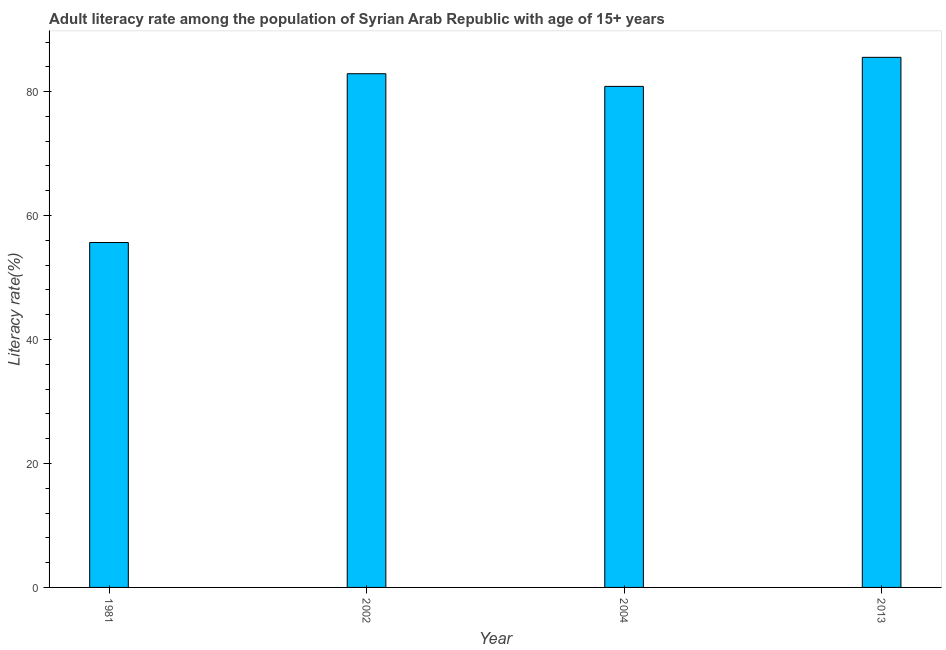Does the graph contain any zero values?
Your answer should be compact. No. What is the title of the graph?
Give a very brief answer. Adult literacy rate among the population of Syrian Arab Republic with age of 15+ years. What is the label or title of the Y-axis?
Your answer should be compact. Literacy rate(%). What is the adult literacy rate in 1981?
Make the answer very short. 55.65. Across all years, what is the maximum adult literacy rate?
Your answer should be very brief. 85.53. Across all years, what is the minimum adult literacy rate?
Ensure brevity in your answer.  55.65. In which year was the adult literacy rate maximum?
Offer a very short reply. 2013. What is the sum of the adult literacy rate?
Offer a very short reply. 304.92. What is the difference between the adult literacy rate in 1981 and 2004?
Your response must be concise. -25.19. What is the average adult literacy rate per year?
Offer a very short reply. 76.23. What is the median adult literacy rate?
Offer a terse response. 81.87. In how many years, is the adult literacy rate greater than 8 %?
Offer a terse response. 4. Do a majority of the years between 2002 and 2013 (inclusive) have adult literacy rate greater than 56 %?
Ensure brevity in your answer.  Yes. What is the ratio of the adult literacy rate in 2004 to that in 2013?
Give a very brief answer. 0.94. Is the adult literacy rate in 1981 less than that in 2004?
Your answer should be compact. Yes. Is the difference between the adult literacy rate in 2002 and 2004 greater than the difference between any two years?
Offer a very short reply. No. What is the difference between the highest and the second highest adult literacy rate?
Provide a succinct answer. 2.65. Is the sum of the adult literacy rate in 2002 and 2013 greater than the maximum adult literacy rate across all years?
Your answer should be very brief. Yes. What is the difference between the highest and the lowest adult literacy rate?
Offer a terse response. 29.88. In how many years, is the adult literacy rate greater than the average adult literacy rate taken over all years?
Make the answer very short. 3. What is the difference between two consecutive major ticks on the Y-axis?
Provide a short and direct response. 20. What is the Literacy rate(%) in 1981?
Offer a very short reply. 55.65. What is the Literacy rate(%) of 2002?
Give a very brief answer. 82.89. What is the Literacy rate(%) of 2004?
Give a very brief answer. 80.84. What is the Literacy rate(%) of 2013?
Your answer should be compact. 85.53. What is the difference between the Literacy rate(%) in 1981 and 2002?
Your response must be concise. -27.23. What is the difference between the Literacy rate(%) in 1981 and 2004?
Ensure brevity in your answer.  -25.19. What is the difference between the Literacy rate(%) in 1981 and 2013?
Make the answer very short. -29.88. What is the difference between the Literacy rate(%) in 2002 and 2004?
Offer a very short reply. 2.04. What is the difference between the Literacy rate(%) in 2002 and 2013?
Your answer should be compact. -2.65. What is the difference between the Literacy rate(%) in 2004 and 2013?
Make the answer very short. -4.69. What is the ratio of the Literacy rate(%) in 1981 to that in 2002?
Make the answer very short. 0.67. What is the ratio of the Literacy rate(%) in 1981 to that in 2004?
Make the answer very short. 0.69. What is the ratio of the Literacy rate(%) in 1981 to that in 2013?
Keep it short and to the point. 0.65. What is the ratio of the Literacy rate(%) in 2002 to that in 2004?
Your answer should be very brief. 1.02. What is the ratio of the Literacy rate(%) in 2004 to that in 2013?
Offer a terse response. 0.94. 